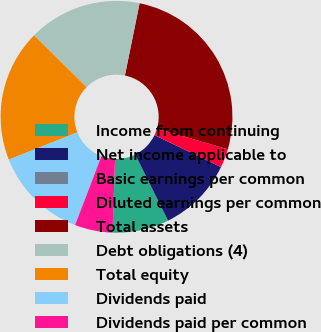Convert chart to OTSL. <chart><loc_0><loc_0><loc_500><loc_500><pie_chart><fcel>Income from continuing<fcel>Net income applicable to<fcel>Basic earnings per common<fcel>Diluted earnings per common<fcel>Total assets<fcel>Debt obligations (4)<fcel>Total equity<fcel>Dividends paid<fcel>Dividends paid per common<nl><fcel>7.89%<fcel>10.53%<fcel>0.0%<fcel>2.63%<fcel>26.32%<fcel>15.79%<fcel>18.42%<fcel>13.16%<fcel>5.26%<nl></chart> 